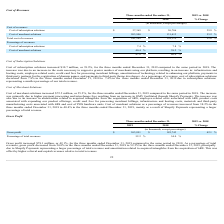From Shopify's financial document, How much is the cost of subscriptions solutions revenue for both financial year ends (in chronological order)? The document shows two values: $ 26,706 and $ 37,369 (in thousands). From the document: "Cost of subscription solutions $ 37,369 $ 26,706 39.9 % Cost of subscription solutions $ 37,369 $ 26,706 39.9 %..." Also, How much is the cost of merchant solutions revenue for both financial year ends (in chronological order)? The document shows two values: 131,413 and 203,900 (in thousands). From the document: "Cost of merchant solutions 203,900 131,413 55.2 % Cost of merchant solutions 203,900 131,413 55.2 %..." Also, How much is the total cost of revenues for both financial year ends (in chronological order)? The document shows two values: $ 158,119 and $ 241,269 (in thousands). From the document: "Total cost of revenues $ 241,269 $ 158,119 52.6 % Total cost of revenues $ 241,269 $ 158,119 52.6 %..." Additionally, Between 2018 and 2019 year end, which year's cost of subscriptions solutions constitutes a higher percentage of revenues? According to the financial document, 2018. The relevant text states: "Three months ended December 31, 2019 vs. 2018..." Additionally, Between 2018 and 2019 year end, which year's cost of merchant solutions constitues a higher percentage of total revenues? According to the financial document, 2019. The relevant text states: "Three months ended December 31, 2019 vs. 2018..." Additionally, Between 2018 and 2019 year end, which year had a higher total cost of revenues? According to the financial document, 2019. The relevant text states: "Three months ended December 31, 2019 vs. 2018..." 